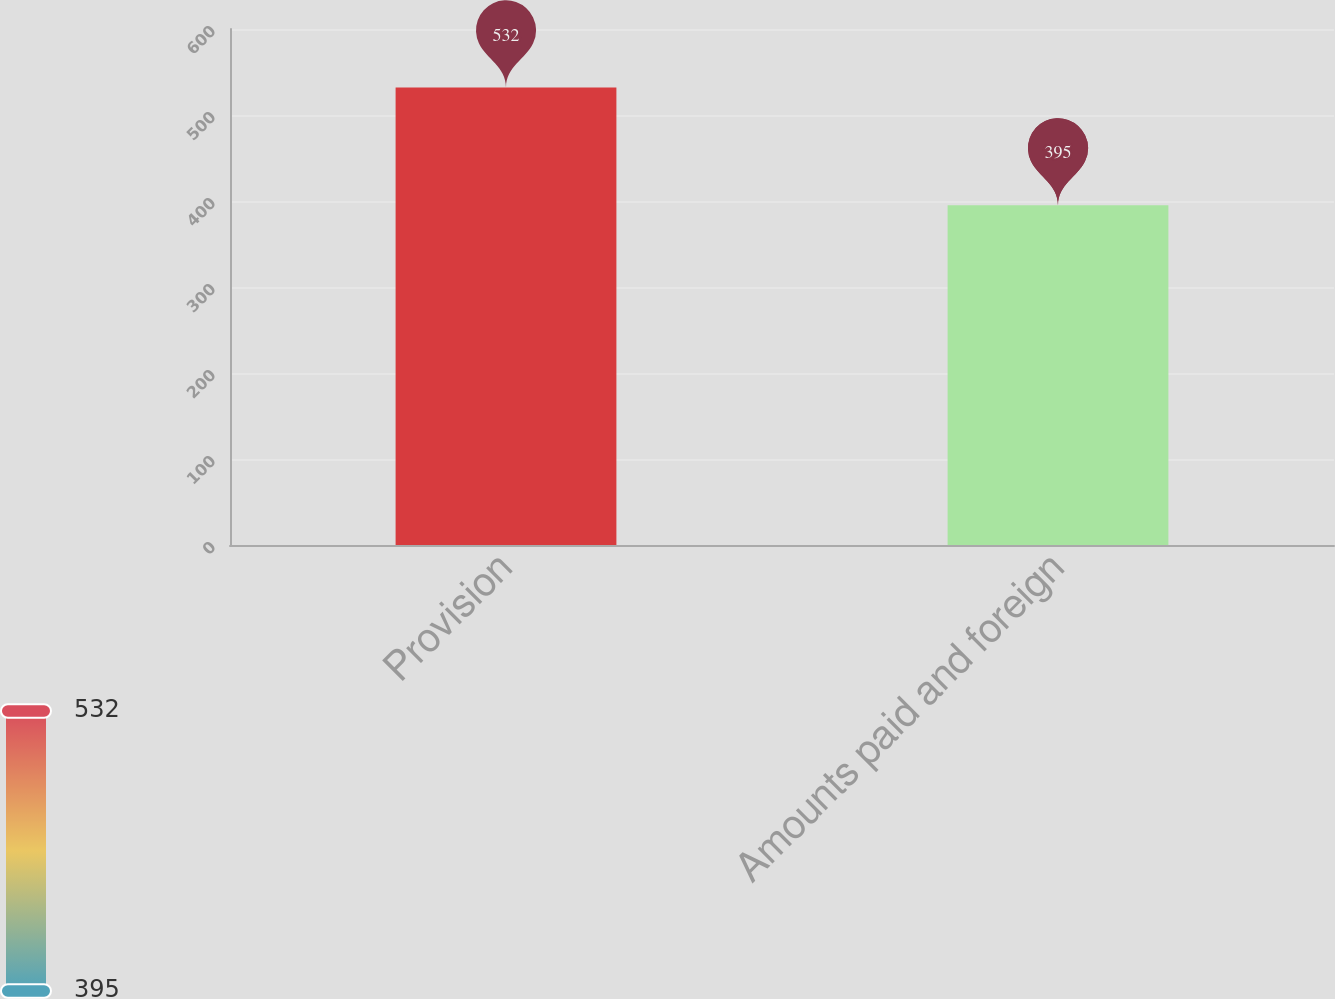<chart> <loc_0><loc_0><loc_500><loc_500><bar_chart><fcel>Provision<fcel>Amounts paid and foreign<nl><fcel>532<fcel>395<nl></chart> 